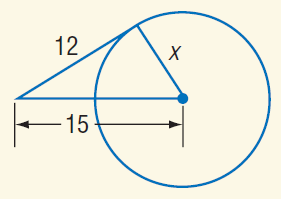Question: Find x. Assume that segments that appear to be tangent are tangent.
Choices:
A. 3
B. 9
C. 12
D. 15
Answer with the letter. Answer: B 